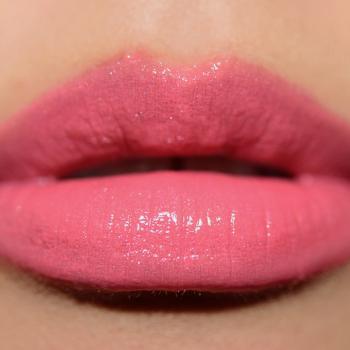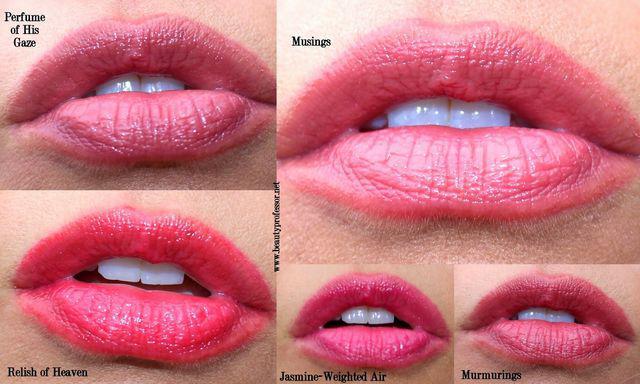The first image is the image on the left, the second image is the image on the right. Given the left and right images, does the statement "The image on the right shows on pair of lips wearing makeup." hold true? Answer yes or no. No. The first image is the image on the left, the second image is the image on the right. Given the left and right images, does the statement "There are more than six pairs of lips in total." hold true? Answer yes or no. No. 